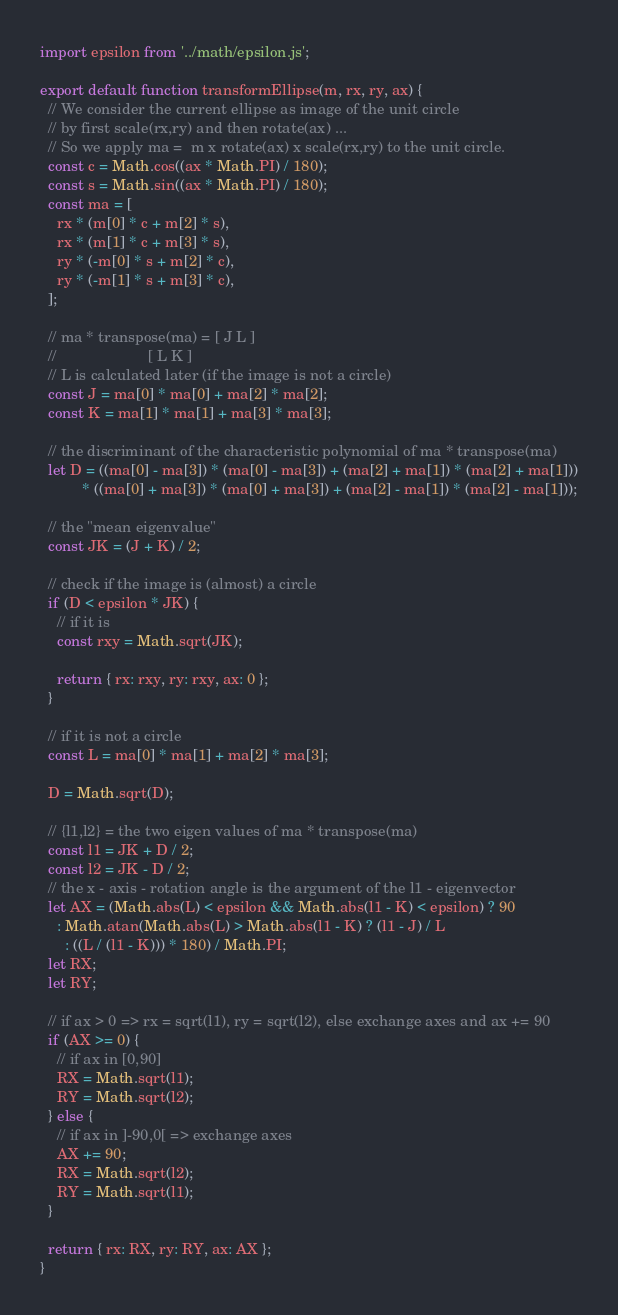<code> <loc_0><loc_0><loc_500><loc_500><_JavaScript_>import epsilon from '../math/epsilon.js';

export default function transformEllipse(m, rx, ry, ax) {
  // We consider the current ellipse as image of the unit circle
  // by first scale(rx,ry) and then rotate(ax) ...
  // So we apply ma =  m x rotate(ax) x scale(rx,ry) to the unit circle.
  const c = Math.cos((ax * Math.PI) / 180);
  const s = Math.sin((ax * Math.PI) / 180);
  const ma = [
    rx * (m[0] * c + m[2] * s),
    rx * (m[1] * c + m[3] * s),
    ry * (-m[0] * s + m[2] * c),
    ry * (-m[1] * s + m[3] * c),
  ];

  // ma * transpose(ma) = [ J L ]
  //                      [ L K ]
  // L is calculated later (if the image is not a circle)
  const J = ma[0] * ma[0] + ma[2] * ma[2];
  const K = ma[1] * ma[1] + ma[3] * ma[3];

  // the discriminant of the characteristic polynomial of ma * transpose(ma)
  let D = ((ma[0] - ma[3]) * (ma[0] - ma[3]) + (ma[2] + ma[1]) * (ma[2] + ma[1]))
          * ((ma[0] + ma[3]) * (ma[0] + ma[3]) + (ma[2] - ma[1]) * (ma[2] - ma[1]));

  // the "mean eigenvalue"
  const JK = (J + K) / 2;

  // check if the image is (almost) a circle
  if (D < epsilon * JK) {
    // if it is
    const rxy = Math.sqrt(JK);

    return { rx: rxy, ry: rxy, ax: 0 };
  }

  // if it is not a circle
  const L = ma[0] * ma[1] + ma[2] * ma[3];

  D = Math.sqrt(D);

  // {l1,l2} = the two eigen values of ma * transpose(ma)
  const l1 = JK + D / 2;
  const l2 = JK - D / 2;
  // the x - axis - rotation angle is the argument of the l1 - eigenvector
  let AX = (Math.abs(L) < epsilon && Math.abs(l1 - K) < epsilon) ? 90
    : Math.atan(Math.abs(L) > Math.abs(l1 - K) ? (l1 - J) / L
      : ((L / (l1 - K))) * 180) / Math.PI;
  let RX;
  let RY;

  // if ax > 0 => rx = sqrt(l1), ry = sqrt(l2), else exchange axes and ax += 90
  if (AX >= 0) {
    // if ax in [0,90]
    RX = Math.sqrt(l1);
    RY = Math.sqrt(l2);
  } else {
    // if ax in ]-90,0[ => exchange axes
    AX += 90;
    RX = Math.sqrt(l2);
    RY = Math.sqrt(l1);
  }

  return { rx: RX, ry: RY, ax: AX };
}
</code> 